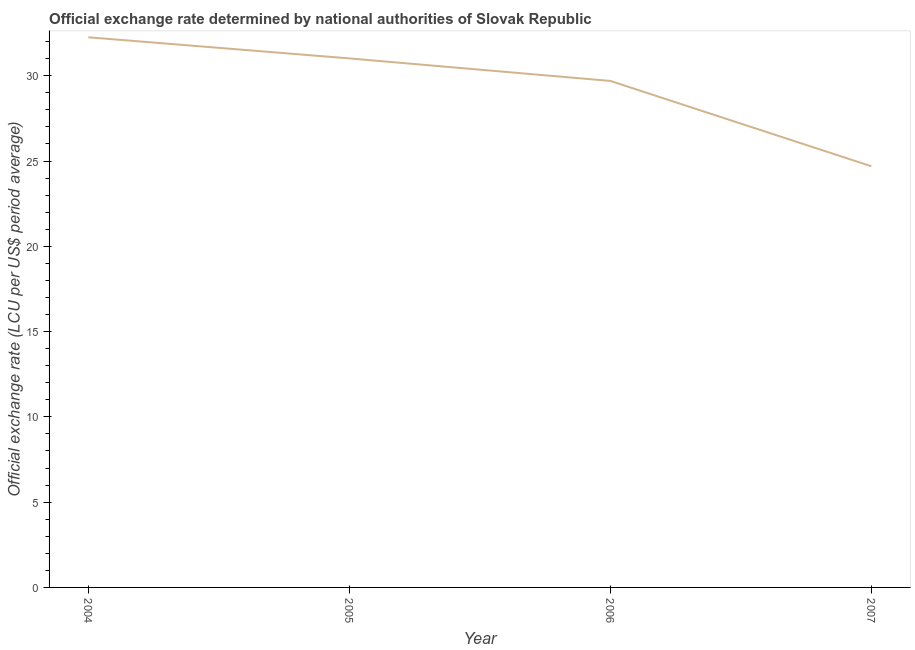What is the official exchange rate in 2004?
Provide a short and direct response. 32.26. Across all years, what is the maximum official exchange rate?
Offer a very short reply. 32.26. Across all years, what is the minimum official exchange rate?
Offer a very short reply. 24.69. What is the sum of the official exchange rate?
Your answer should be very brief. 117.67. What is the difference between the official exchange rate in 2004 and 2005?
Your answer should be compact. 1.24. What is the average official exchange rate per year?
Ensure brevity in your answer.  29.42. What is the median official exchange rate?
Make the answer very short. 30.36. In how many years, is the official exchange rate greater than 12 ?
Keep it short and to the point. 4. What is the ratio of the official exchange rate in 2004 to that in 2006?
Your response must be concise. 1.09. What is the difference between the highest and the second highest official exchange rate?
Your answer should be compact. 1.24. What is the difference between the highest and the lowest official exchange rate?
Provide a short and direct response. 7.56. What is the difference between two consecutive major ticks on the Y-axis?
Provide a short and direct response. 5. Are the values on the major ticks of Y-axis written in scientific E-notation?
Make the answer very short. No. Does the graph contain any zero values?
Provide a short and direct response. No. Does the graph contain grids?
Provide a short and direct response. No. What is the title of the graph?
Provide a succinct answer. Official exchange rate determined by national authorities of Slovak Republic. What is the label or title of the X-axis?
Make the answer very short. Year. What is the label or title of the Y-axis?
Provide a short and direct response. Official exchange rate (LCU per US$ period average). What is the Official exchange rate (LCU per US$ period average) in 2004?
Offer a very short reply. 32.26. What is the Official exchange rate (LCU per US$ period average) of 2005?
Offer a terse response. 31.02. What is the Official exchange rate (LCU per US$ period average) of 2006?
Your response must be concise. 29.7. What is the Official exchange rate (LCU per US$ period average) in 2007?
Provide a short and direct response. 24.69. What is the difference between the Official exchange rate (LCU per US$ period average) in 2004 and 2005?
Ensure brevity in your answer.  1.24. What is the difference between the Official exchange rate (LCU per US$ period average) in 2004 and 2006?
Make the answer very short. 2.56. What is the difference between the Official exchange rate (LCU per US$ period average) in 2004 and 2007?
Provide a succinct answer. 7.56. What is the difference between the Official exchange rate (LCU per US$ period average) in 2005 and 2006?
Offer a very short reply. 1.32. What is the difference between the Official exchange rate (LCU per US$ period average) in 2005 and 2007?
Ensure brevity in your answer.  6.32. What is the difference between the Official exchange rate (LCU per US$ period average) in 2006 and 2007?
Offer a very short reply. 5. What is the ratio of the Official exchange rate (LCU per US$ period average) in 2004 to that in 2005?
Your answer should be compact. 1.04. What is the ratio of the Official exchange rate (LCU per US$ period average) in 2004 to that in 2006?
Offer a very short reply. 1.09. What is the ratio of the Official exchange rate (LCU per US$ period average) in 2004 to that in 2007?
Provide a short and direct response. 1.31. What is the ratio of the Official exchange rate (LCU per US$ period average) in 2005 to that in 2006?
Provide a succinct answer. 1.04. What is the ratio of the Official exchange rate (LCU per US$ period average) in 2005 to that in 2007?
Your answer should be very brief. 1.26. What is the ratio of the Official exchange rate (LCU per US$ period average) in 2006 to that in 2007?
Offer a very short reply. 1.2. 